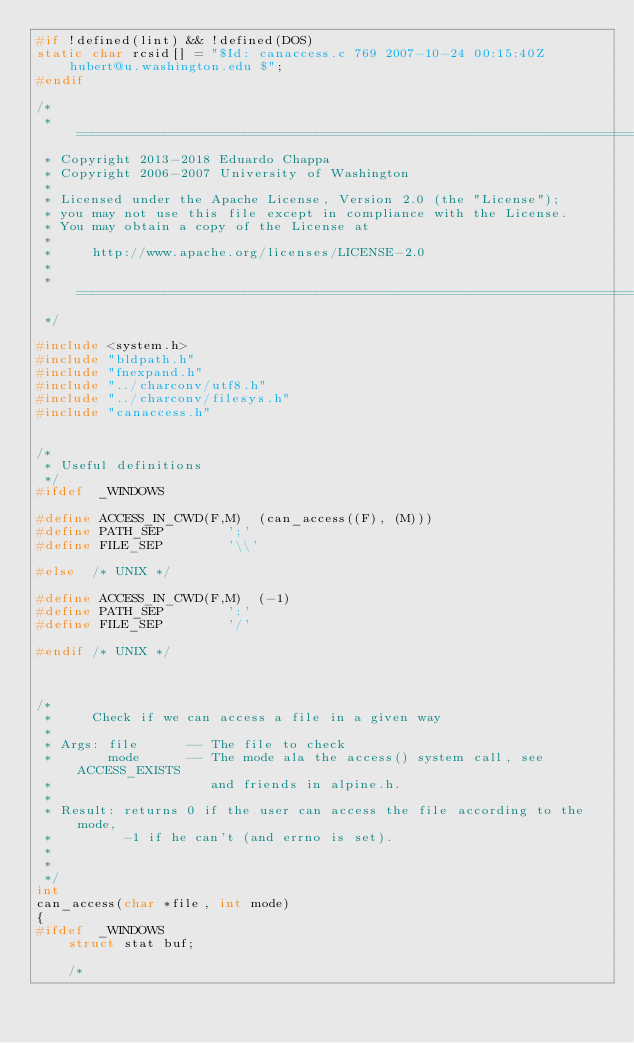Convert code to text. <code><loc_0><loc_0><loc_500><loc_500><_C_>#if !defined(lint) && !defined(DOS)
static char rcsid[] = "$Id: canaccess.c 769 2007-10-24 00:15:40Z hubert@u.washington.edu $";
#endif

/*
 * ========================================================================
 * Copyright 2013-2018 Eduardo Chappa
 * Copyright 2006-2007 University of Washington
 *
 * Licensed under the Apache License, Version 2.0 (the "License");
 * you may not use this file except in compliance with the License.
 * You may obtain a copy of the License at
 *
 *     http://www.apache.org/licenses/LICENSE-2.0
 *
 * ========================================================================
 */

#include <system.h>
#include "bldpath.h"
#include "fnexpand.h"
#include "../charconv/utf8.h"
#include "../charconv/filesys.h"
#include "canaccess.h"


/*
 * Useful definitions
 */
#ifdef	_WINDOWS

#define ACCESS_IN_CWD(F,M)	(can_access((F), (M)))
#define	PATH_SEP		';'
#define	FILE_SEP		'\\'

#else  /* UNIX */

#define ACCESS_IN_CWD(F,M)	(-1)
#define	PATH_SEP		':'
#define	FILE_SEP		'/'

#endif /* UNIX */



/*
 *     Check if we can access a file in a given way
 *
 * Args: file      -- The file to check
 *       mode      -- The mode ala the access() system call, see ACCESS_EXISTS
 *                    and friends in alpine.h.
 *
 * Result: returns 0 if the user can access the file according to the mode,
 *         -1 if he can't (and errno is set).
 *
 *
 */
int
can_access(char *file, int mode)
{
#ifdef	_WINDOWS
    struct stat buf;

    /*</code> 